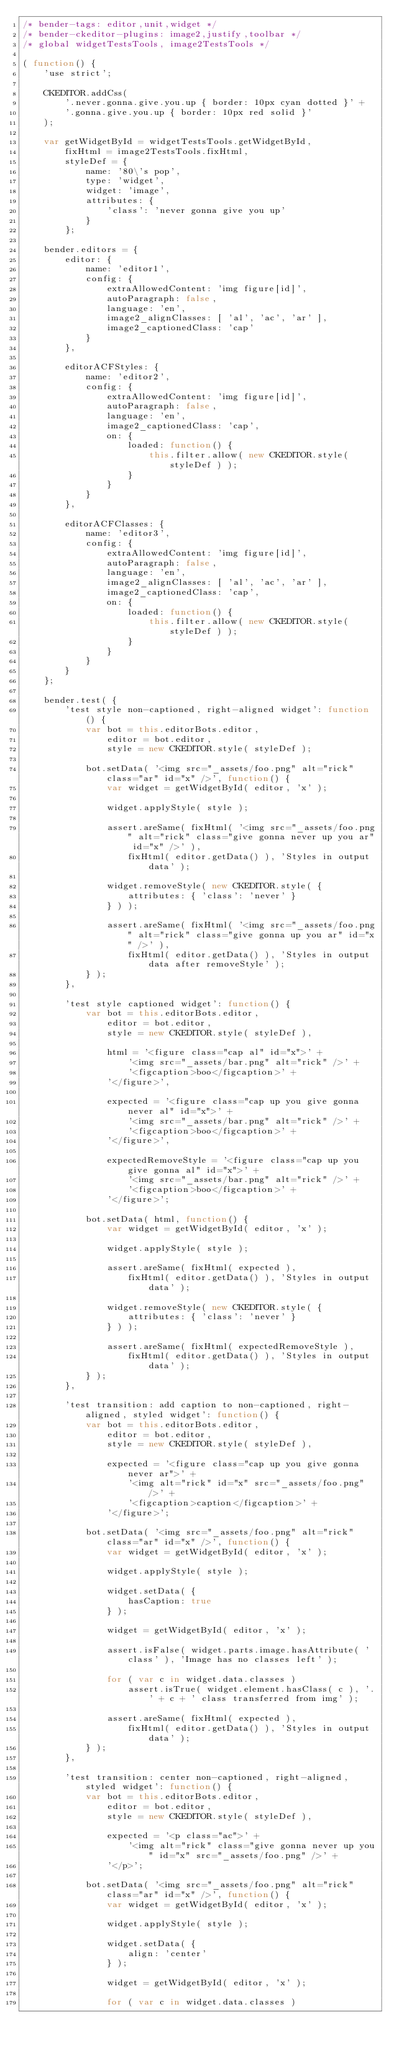<code> <loc_0><loc_0><loc_500><loc_500><_JavaScript_>/* bender-tags: editor,unit,widget */
/* bender-ckeditor-plugins: image2,justify,toolbar */
/* global widgetTestsTools, image2TestsTools */

( function() {
	'use strict';

	CKEDITOR.addCss(
		'.never.gonna.give.you.up { border: 10px cyan dotted }' +
		'.gonna.give.you.up { border: 10px red solid }'
	);

	var getWidgetById = widgetTestsTools.getWidgetById,
		fixHtml = image2TestsTools.fixHtml,
		styleDef = {
			name: '80\'s pop',
			type: 'widget',
			widget: 'image',
			attributes: {
				'class': 'never gonna give you up'
			}
		};

	bender.editors = {
		editor: {
			name: 'editor1',
			config: {
				extraAllowedContent: 'img figure[id]',
				autoParagraph: false,
				language: 'en',
				image2_alignClasses: [ 'al', 'ac', 'ar' ],
				image2_captionedClass: 'cap'
			}
		},

		editorACFStyles: {
			name: 'editor2',
			config: {
				extraAllowedContent: 'img figure[id]',
				autoParagraph: false,
				language: 'en',
				image2_captionedClass: 'cap',
				on: {
					loaded: function() {
						this.filter.allow( new CKEDITOR.style( styleDef ) );
					}
				}
			}
		},

		editorACFClasses: {
			name: 'editor3',
			config: {
				extraAllowedContent: 'img figure[id]',
				autoParagraph: false,
				language: 'en',
				image2_alignClasses: [ 'al', 'ac', 'ar' ],
				image2_captionedClass: 'cap',
				on: {
					loaded: function() {
						this.filter.allow( new CKEDITOR.style( styleDef ) );
					}
				}
			}
		}
	};

	bender.test( {
		'test style non-captioned, right-aligned widget': function() {
			var bot = this.editorBots.editor,
				editor = bot.editor,
				style = new CKEDITOR.style( styleDef );

			bot.setData( '<img src="_assets/foo.png" alt="rick" class="ar" id="x" />', function() {
				var widget = getWidgetById( editor, 'x' );

				widget.applyStyle( style );

				assert.areSame( fixHtml( '<img src="_assets/foo.png" alt="rick" class="give gonna never up you ar" id="x" />' ),
					fixHtml( editor.getData() ), 'Styles in output data' );

				widget.removeStyle( new CKEDITOR.style( {
					attributes: { 'class': 'never' }
				} ) );

				assert.areSame( fixHtml( '<img src="_assets/foo.png" alt="rick" class="give gonna up you ar" id="x" />' ),
					fixHtml( editor.getData() ), 'Styles in output data after removeStyle' );
			} );
		},

		'test style captioned widget': function() {
			var bot = this.editorBots.editor,
				editor = bot.editor,
				style = new CKEDITOR.style( styleDef ),

				html = '<figure class="cap al" id="x">' +
					'<img src="_assets/bar.png" alt="rick" />' +
					'<figcaption>boo</figcaption>' +
				'</figure>',

				expected = '<figure class="cap up you give gonna never al" id="x">' +
					'<img src="_assets/bar.png" alt="rick" />' +
					'<figcaption>boo</figcaption>' +
				'</figure>',

				expectedRemoveStyle = '<figure class="cap up you give gonna al" id="x">' +
					'<img src="_assets/bar.png" alt="rick" />' +
					'<figcaption>boo</figcaption>' +
				'</figure>';

			bot.setData( html, function() {
				var widget = getWidgetById( editor, 'x' );

				widget.applyStyle( style );

				assert.areSame( fixHtml( expected ),
					fixHtml( editor.getData() ), 'Styles in output data' );

				widget.removeStyle( new CKEDITOR.style( {
					attributes: { 'class': 'never' }
				} ) );

				assert.areSame( fixHtml( expectedRemoveStyle ),
					fixHtml( editor.getData() ), 'Styles in output data' );
			} );
		},

		'test transition: add caption to non-captioned, right-aligned, styled widget': function() {
			var bot = this.editorBots.editor,
				editor = bot.editor,
				style = new CKEDITOR.style( styleDef ),

				expected = '<figure class="cap up you give gonna never ar">' +
					'<img alt="rick" id="x" src="_assets/foo.png" />' +
					'<figcaption>caption</figcaption>' +
				'</figure>';

			bot.setData( '<img src="_assets/foo.png" alt="rick" class="ar" id="x" />', function() {
				var widget = getWidgetById( editor, 'x' );

				widget.applyStyle( style );

				widget.setData( {
					hasCaption: true
				} );

				widget = getWidgetById( editor, 'x' );

				assert.isFalse( widget.parts.image.hasAttribute( 'class' ), 'Image has no classes left' );

				for ( var c in widget.data.classes )
					assert.isTrue( widget.element.hasClass( c ), '.' + c + ' class transferred from img' );

				assert.areSame( fixHtml( expected ),
					fixHtml( editor.getData() ), 'Styles in output data' );
			} );
		},

		'test transition: center non-captioned, right-aligned, styled widget': function() {
			var bot = this.editorBots.editor,
				editor = bot.editor,
				style = new CKEDITOR.style( styleDef ),

				expected = '<p class="ac">' +
					'<img alt="rick" class="give gonna never up you" id="x" src="_assets/foo.png" />' +
				'</p>';

			bot.setData( '<img src="_assets/foo.png" alt="rick" class="ar" id="x" />', function() {
				var widget = getWidgetById( editor, 'x' );

				widget.applyStyle( style );

				widget.setData( {
					align: 'center'
				} );

				widget = getWidgetById( editor, 'x' );

				for ( var c in widget.data.classes )</code> 